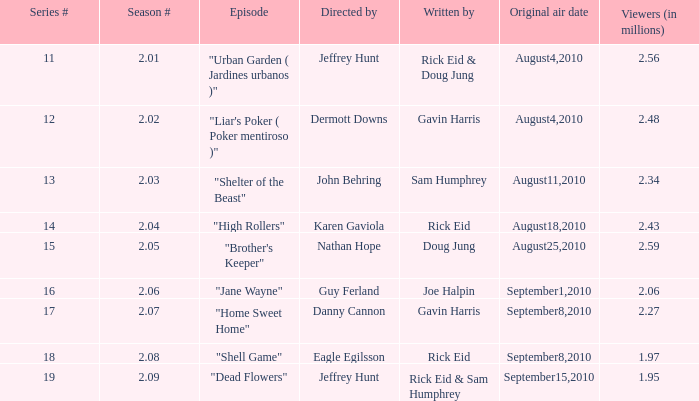08? 18.0. 